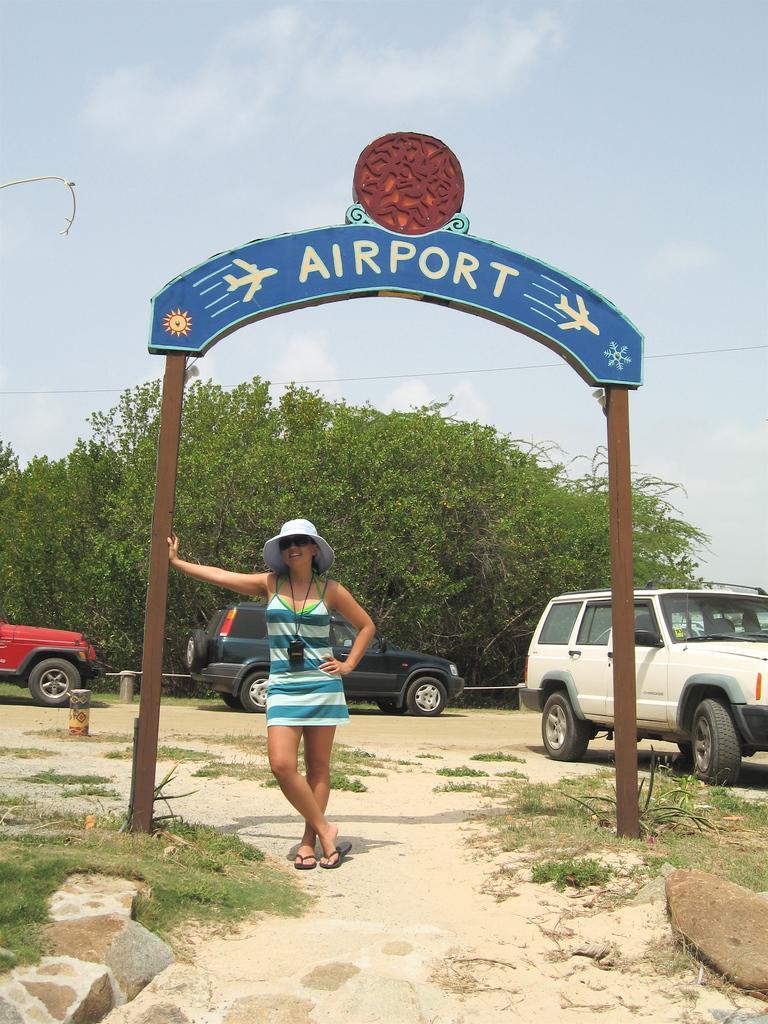How would you summarize this image in a sentence or two? In this picture I can see a woman standing, there is grass, rocks, vehicles, there is a board with poles, there are trees, and in the background there is sky. 